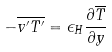Convert formula to latex. <formula><loc_0><loc_0><loc_500><loc_500>- \overline { v ^ { \prime } T ^ { \prime } } = \epsilon _ { H } \frac { \partial \overline { T } } { \partial y }</formula> 